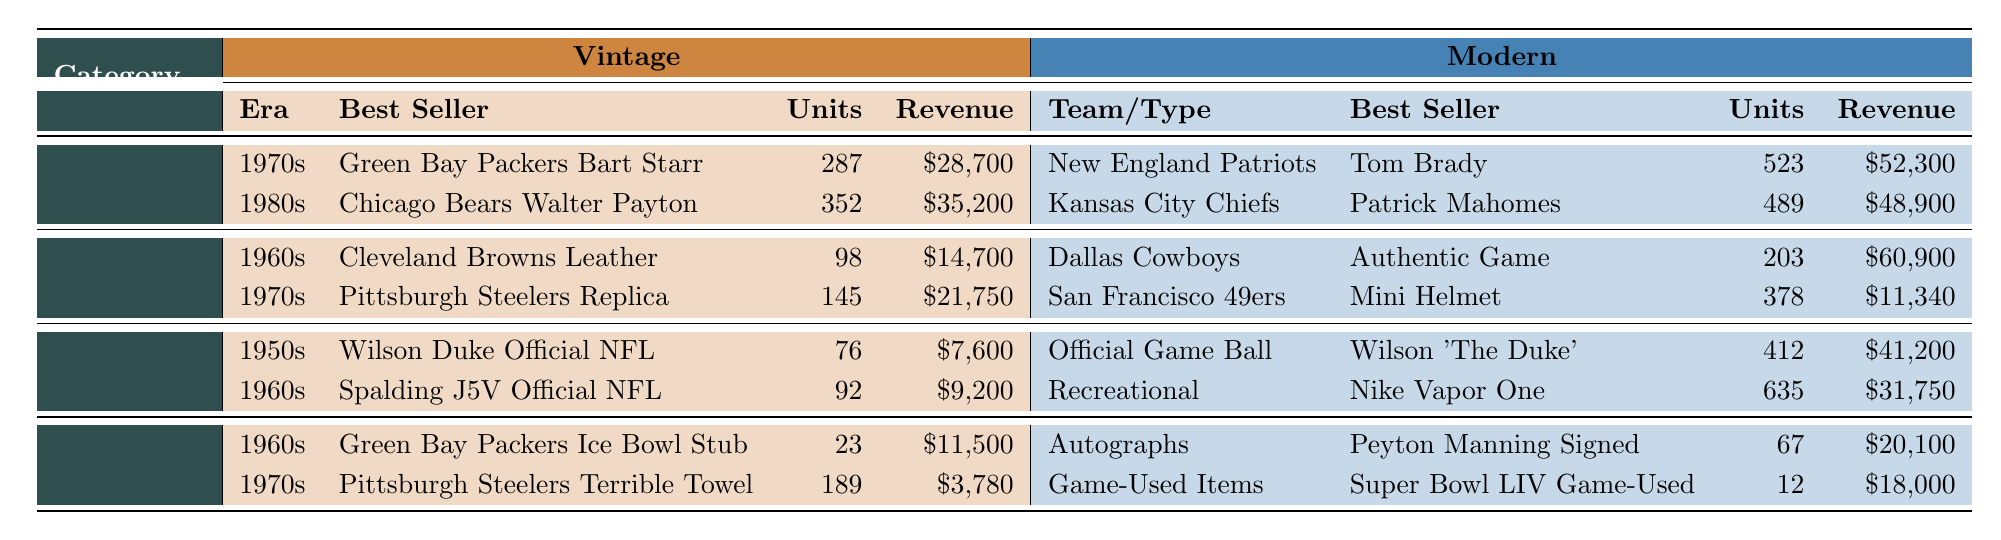What is the best-selling vintage jersey from the 1980s? The table shows that the best-selling vintage jersey from the 1980s is the Chicago Bears Walter Payton Jersey.
Answer: Chicago Bears Walter Payton Jersey How many units of the New England Patriots Tom Brady Jersey were sold? The table indicates that 523 units of the New England Patriots Tom Brady Jersey were sold.
Answer: 523 What is the total revenue generated from vintage helmets? The revenue from vintage helmets can be calculated by adding the revenues of both helmet entries: $14,700 + $21,750 = $36,450.
Answer: $36,450 Which category had the highest single unit sales for a vintage product? By comparing the units sold across all categories, the highest units sold for a vintage product is 352 for the Chicago Bears Walter Payton Jersey in the Jerseys category.
Answer: Jerseys Is the revenue from the Dallas Cowboys modern helmet greater than the combined revenue of vintage helmets? The revenue from the Dallas Cowboys modern helmet is $60,900 and the combined revenue of vintage helmets is $36,450. Since $60,900 > $36,450, the statement is true.
Answer: Yes What is the average revenue from vintage footballs? The revenues from vintage footballs are $7,600 and $9,200. Average revenue is calculated as ($7,600 + $9,200) / 2 = $8,400.
Answer: $8,400 Which type or team sold more units between vintage and modern footballs? In vintage footballs, 76 and 92 units were sold, totaling 168. In modern footballs, 412 and 635 units were sold, totaling 1,047. Since 1,047 > 168, modern footballs sold more units.
Answer: Modern footballs How many more units were sold of the Nike Vapor One football compared to the Wilson Duke Official NFL Game Ball? The units sold for the Nike Vapor One football is 635 and for the Wilson Duke Official NFL Game Ball is 76. The difference is 635 - 76 = 559.
Answer: 559 What is the best seller in memorabilia from the 1970s? According to the table, the best-selling memorabilia from the 1970s is the Pittsburgh Steelers Terrible Towel.
Answer: Pittsburgh Steelers Terrible Towel Which category shows a higher total revenue for modern products, helmets or jerseys? For modern helmets, the total revenue is $60,900 + $11,340 = $72,240, while for modern jerseys, it is $52,300 + $48,900 = $101,200. Since $101,200 > $72,240, jerseys show a higher total revenue.
Answer: Jerseys 